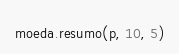<code> <loc_0><loc_0><loc_500><loc_500><_Python_>moeda.resumo(p, 10, 5)
</code> 